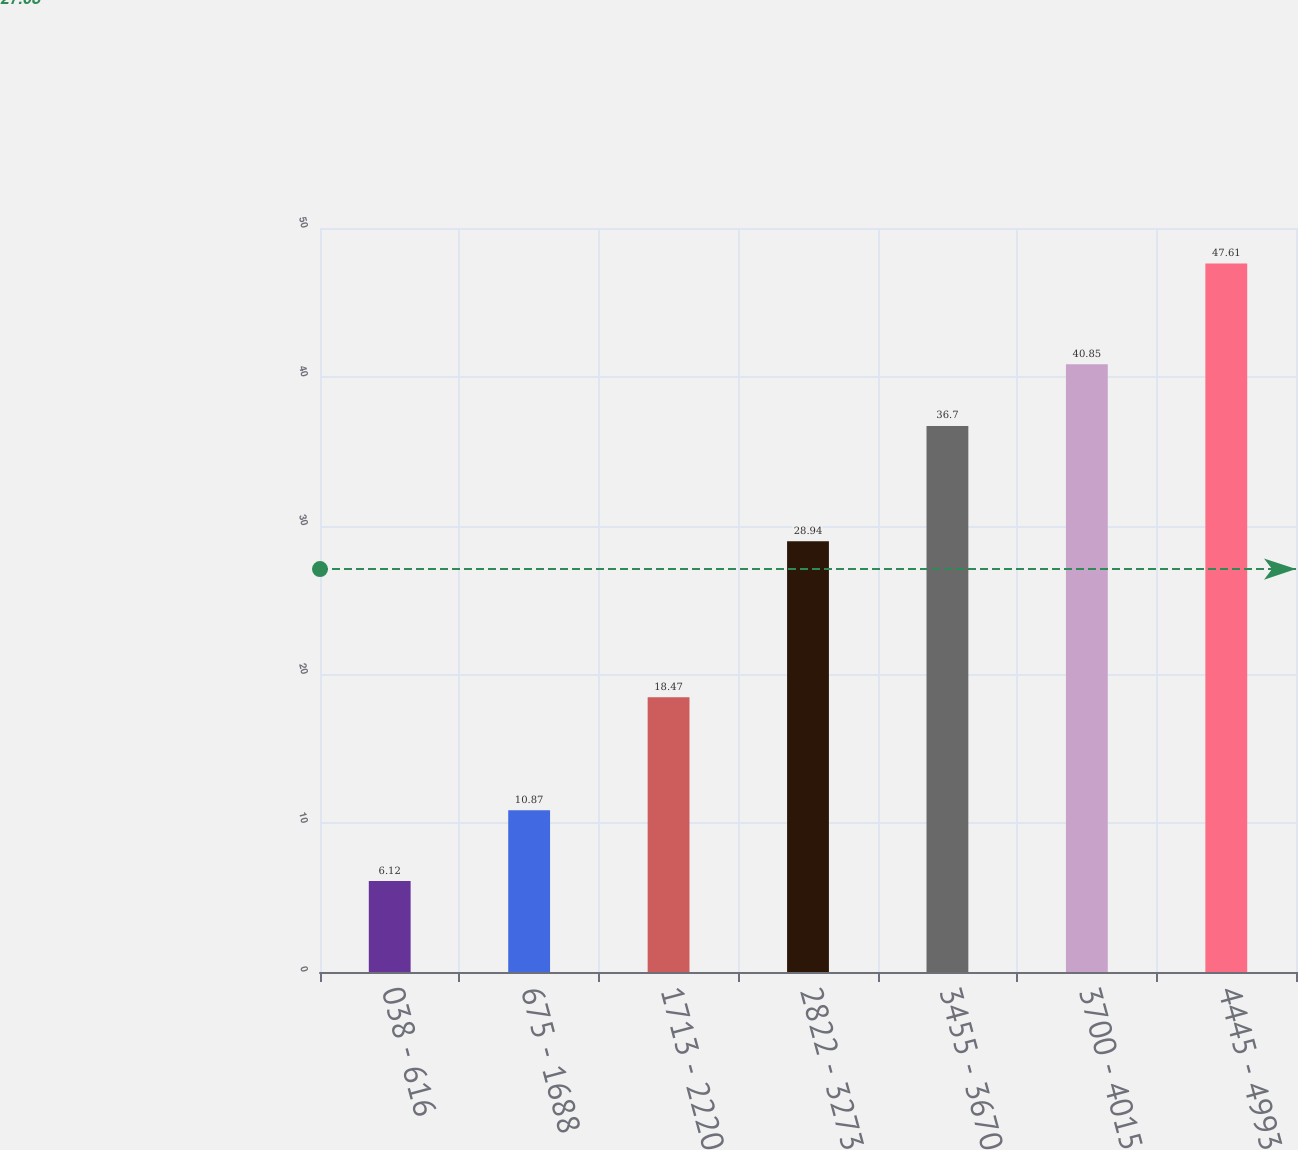Convert chart. <chart><loc_0><loc_0><loc_500><loc_500><bar_chart><fcel>038 - 616<fcel>675 - 1688<fcel>1713 - 2220<fcel>2822 - 3273<fcel>3455 - 3670<fcel>3700 - 4015<fcel>4445 - 4993<nl><fcel>6.12<fcel>10.87<fcel>18.47<fcel>28.94<fcel>36.7<fcel>40.85<fcel>47.61<nl></chart> 